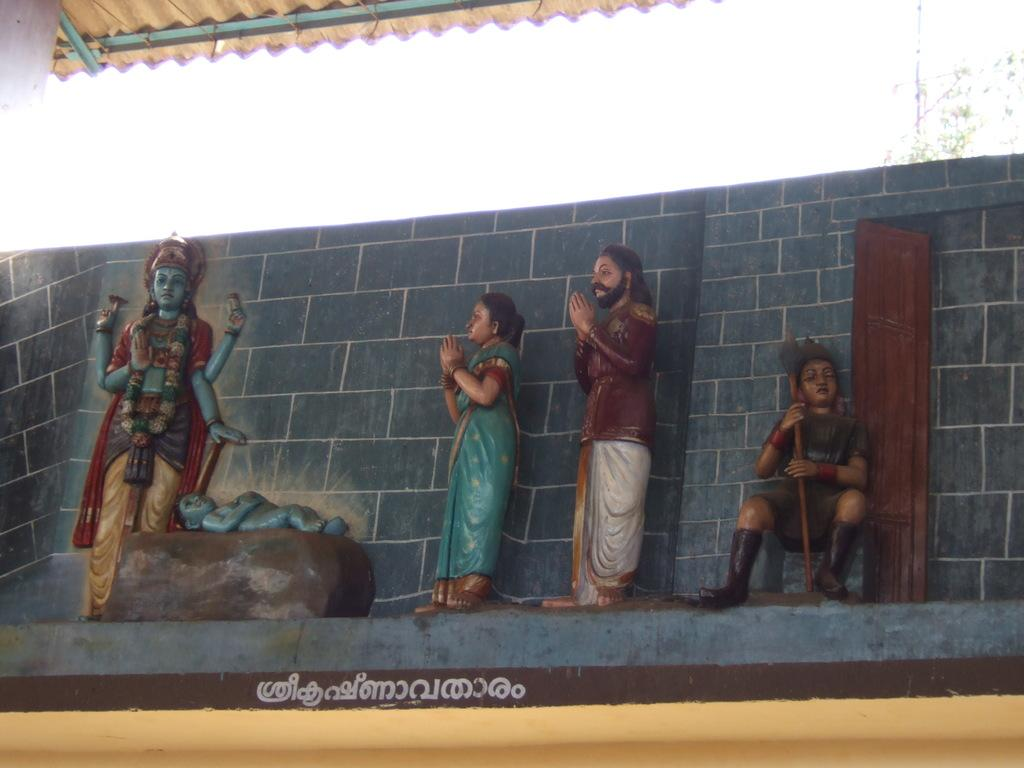Can you describe the main subject or objects in the image? Unfortunately, there are no specific facts provided about the image, so it is impossible to describe the main subject or objects. How many hens can be seen cooking on the stove in the image? There is no information provided about the image, and therefore no hens or stoves can be observed. 